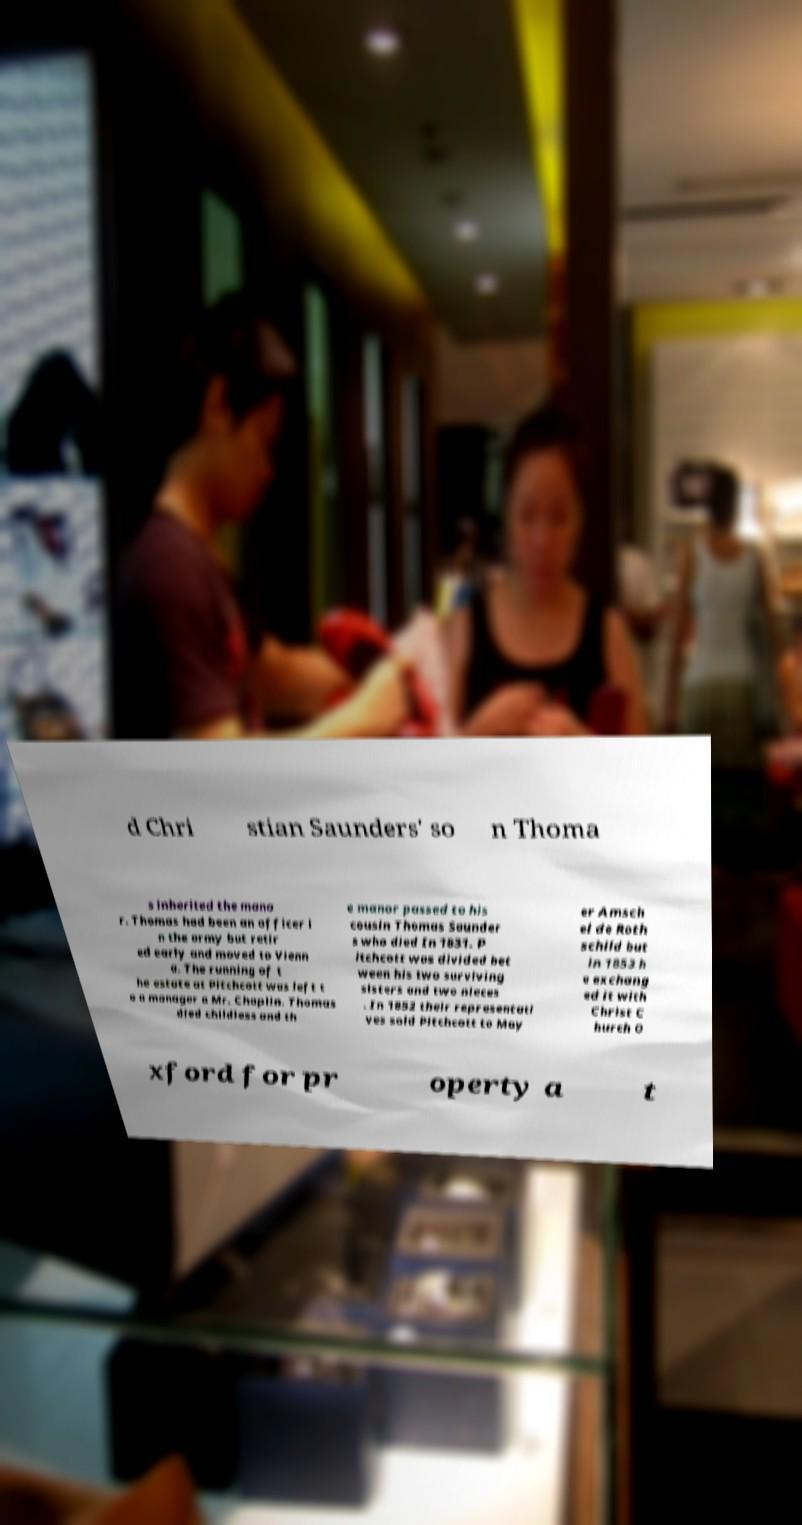Could you extract and type out the text from this image? d Chri stian Saunders' so n Thoma s inherited the mano r. Thomas had been an officer i n the army but retir ed early and moved to Vienn a. The running of t he estate at Pitchcott was left t o a manager a Mr. Chaplin. Thomas died childless and th e manor passed to his cousin Thomas Saunder s who died In 1831. P itchcott was divided bet ween his two surviving sisters and two nieces . In 1852 their representati ves sold Pitchcott to May er Amsch el de Roth schild but in 1853 h e exchang ed it with Christ C hurch O xford for pr operty a t 